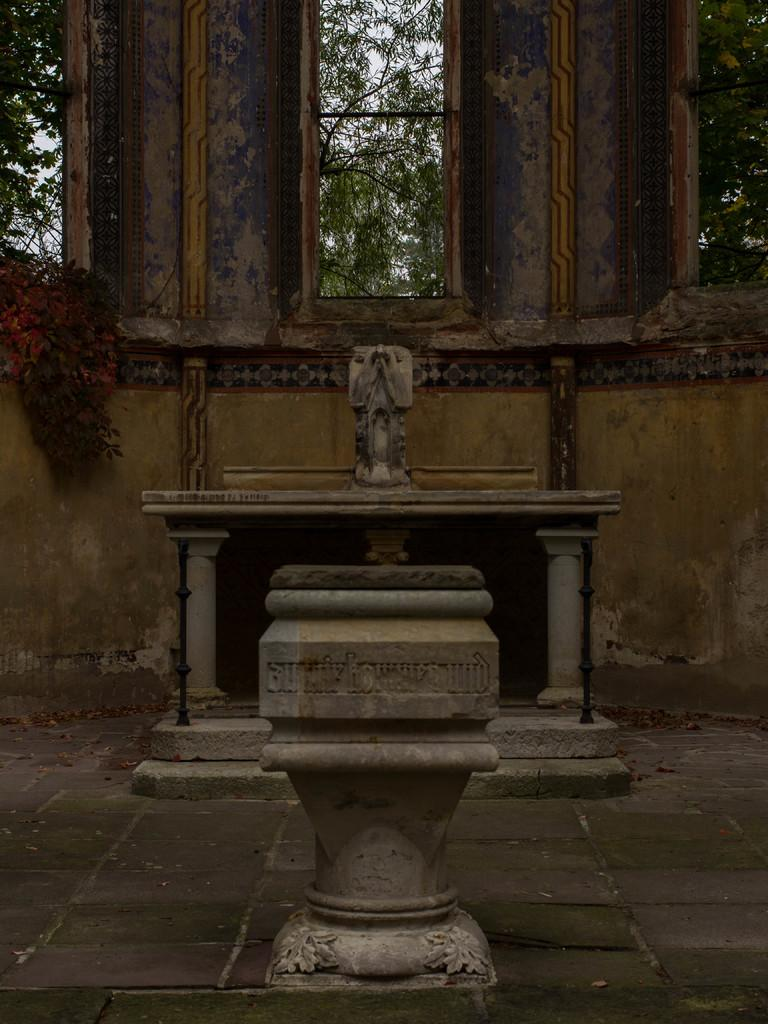What type of structures can be seen in the image? There are walls and windows in the image. What can be seen outside the walls in the image? There are trees in the image. What type of decoration is present in the image? There is carving in the image. What type of objects are present in the image? There are objects in the image. What architectural feature is present in the image? There are stairs in the image. What is the surface that the objects and people are standing on in the image? There is a floor in the image. What specific detail can be observed about the rods in the image? There are black color rods in the image. What is the aftermath of the neck injury in the image? There is no mention of a neck injury or any injury in the image. 